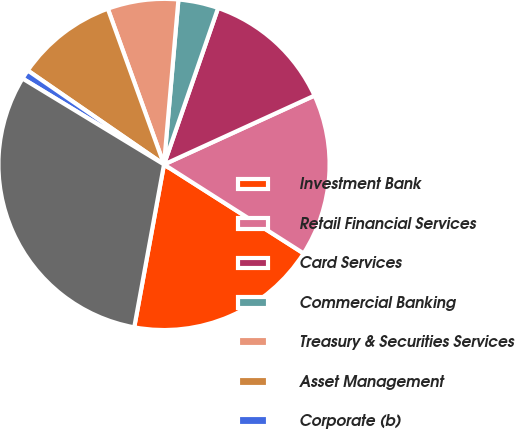Convert chart to OTSL. <chart><loc_0><loc_0><loc_500><loc_500><pie_chart><fcel>Investment Bank<fcel>Retail Financial Services<fcel>Card Services<fcel>Commercial Banking<fcel>Treasury & Securities Services<fcel>Asset Management<fcel>Corporate (b)<fcel>Total<nl><fcel>18.85%<fcel>15.86%<fcel>12.87%<fcel>3.91%<fcel>6.9%<fcel>9.88%<fcel>0.92%<fcel>30.81%<nl></chart> 